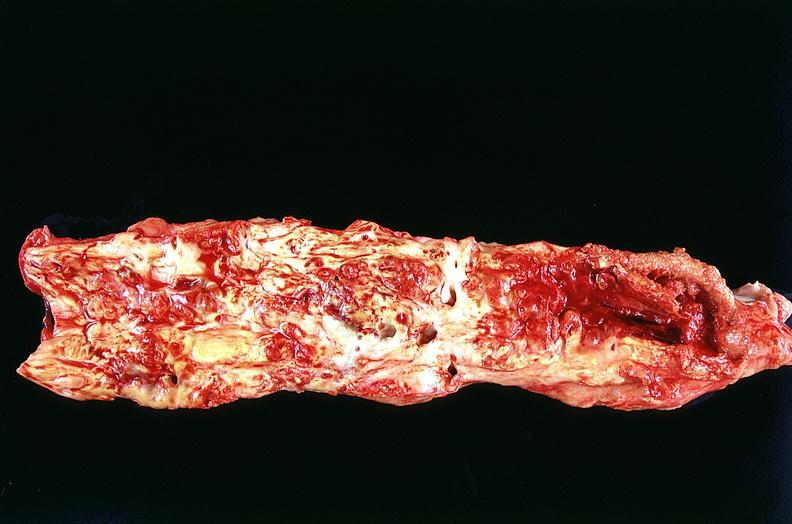s cardiovascular present?
Answer the question using a single word or phrase. Yes 